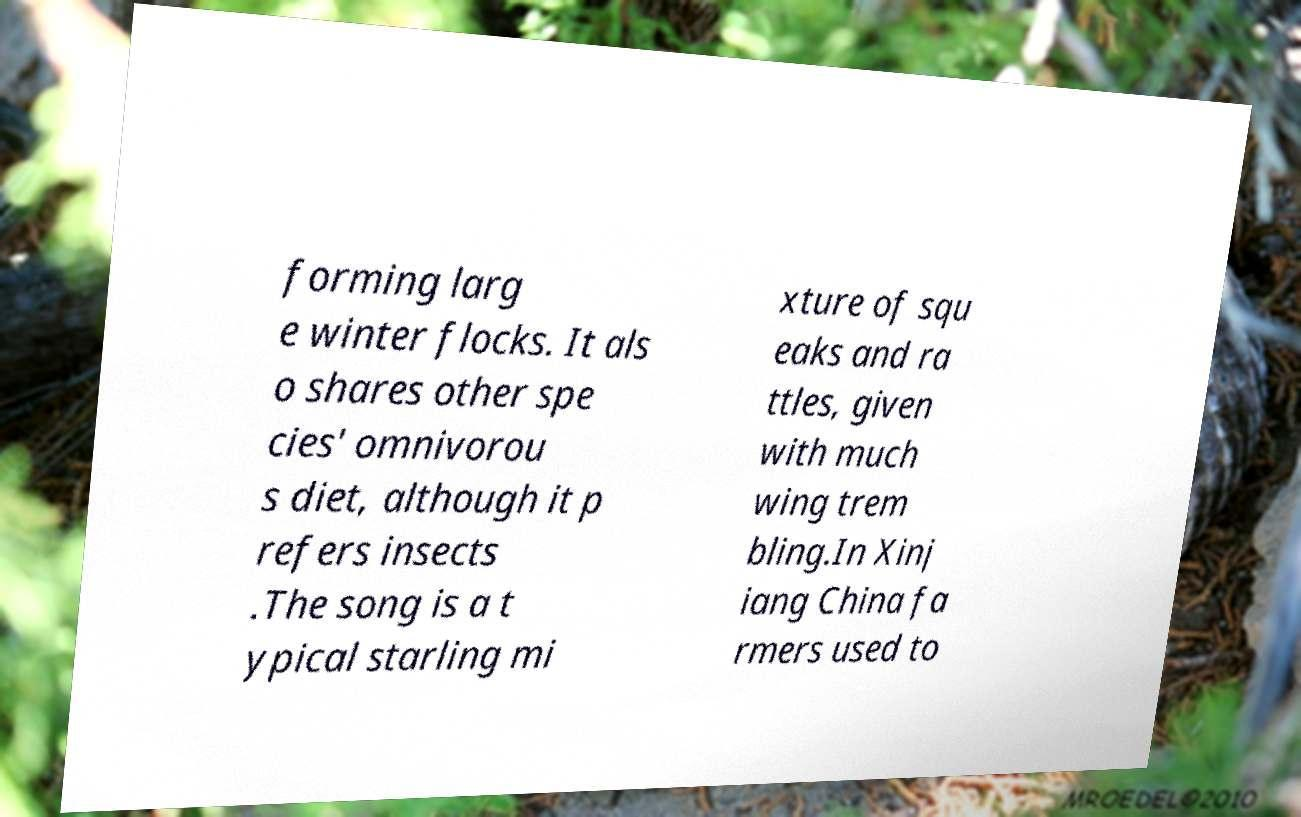Please read and relay the text visible in this image. What does it say? forming larg e winter flocks. It als o shares other spe cies' omnivorou s diet, although it p refers insects .The song is a t ypical starling mi xture of squ eaks and ra ttles, given with much wing trem bling.In Xinj iang China fa rmers used to 